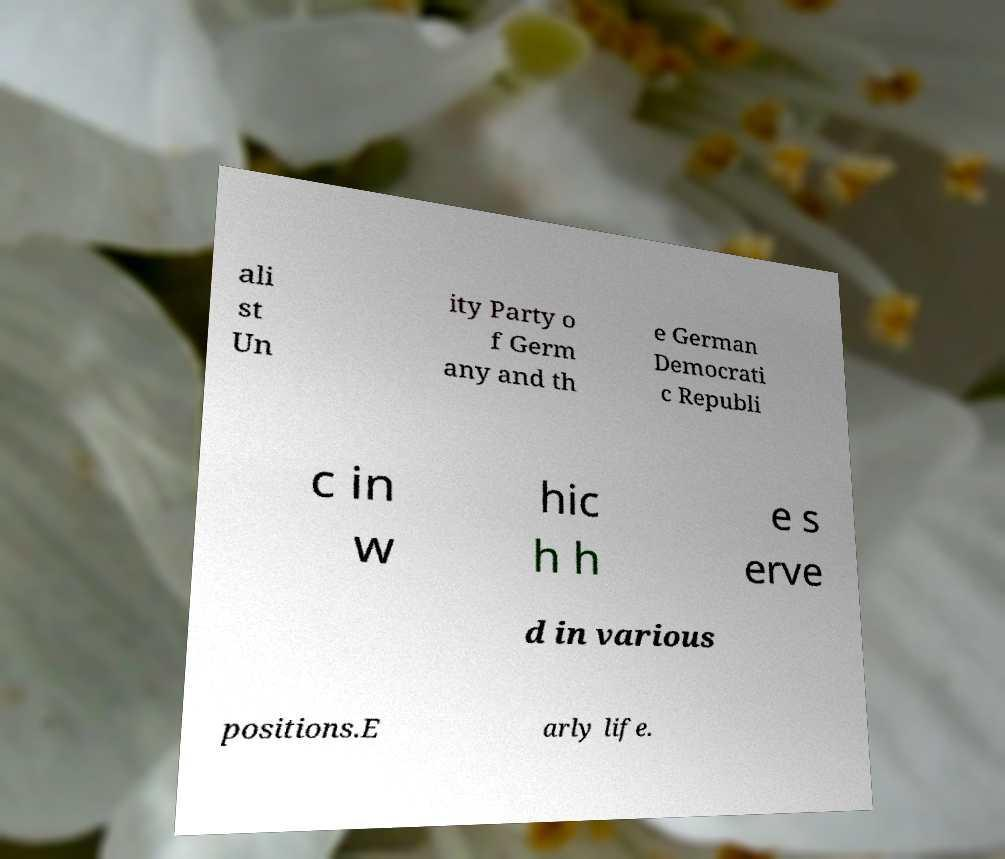Could you extract and type out the text from this image? ali st Un ity Party o f Germ any and th e German Democrati c Republi c in w hic h h e s erve d in various positions.E arly life. 